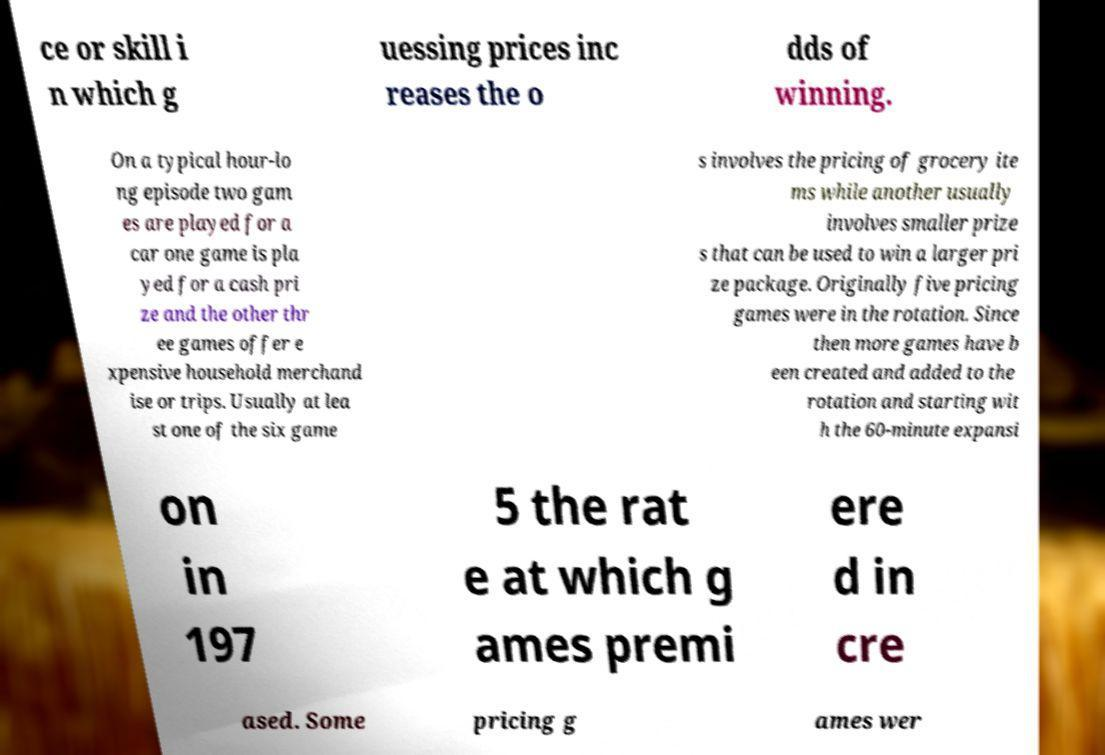There's text embedded in this image that I need extracted. Can you transcribe it verbatim? ce or skill i n which g uessing prices inc reases the o dds of winning. On a typical hour-lo ng episode two gam es are played for a car one game is pla yed for a cash pri ze and the other thr ee games offer e xpensive household merchand ise or trips. Usually at lea st one of the six game s involves the pricing of grocery ite ms while another usually involves smaller prize s that can be used to win a larger pri ze package. Originally five pricing games were in the rotation. Since then more games have b een created and added to the rotation and starting wit h the 60-minute expansi on in 197 5 the rat e at which g ames premi ere d in cre ased. Some pricing g ames wer 